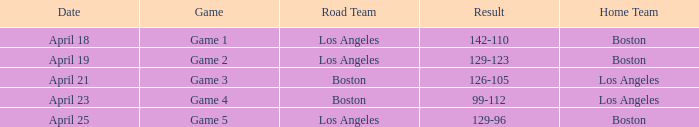WHAT IS THE HOME TEAM, RESULT 99-112? Los Angeles. 